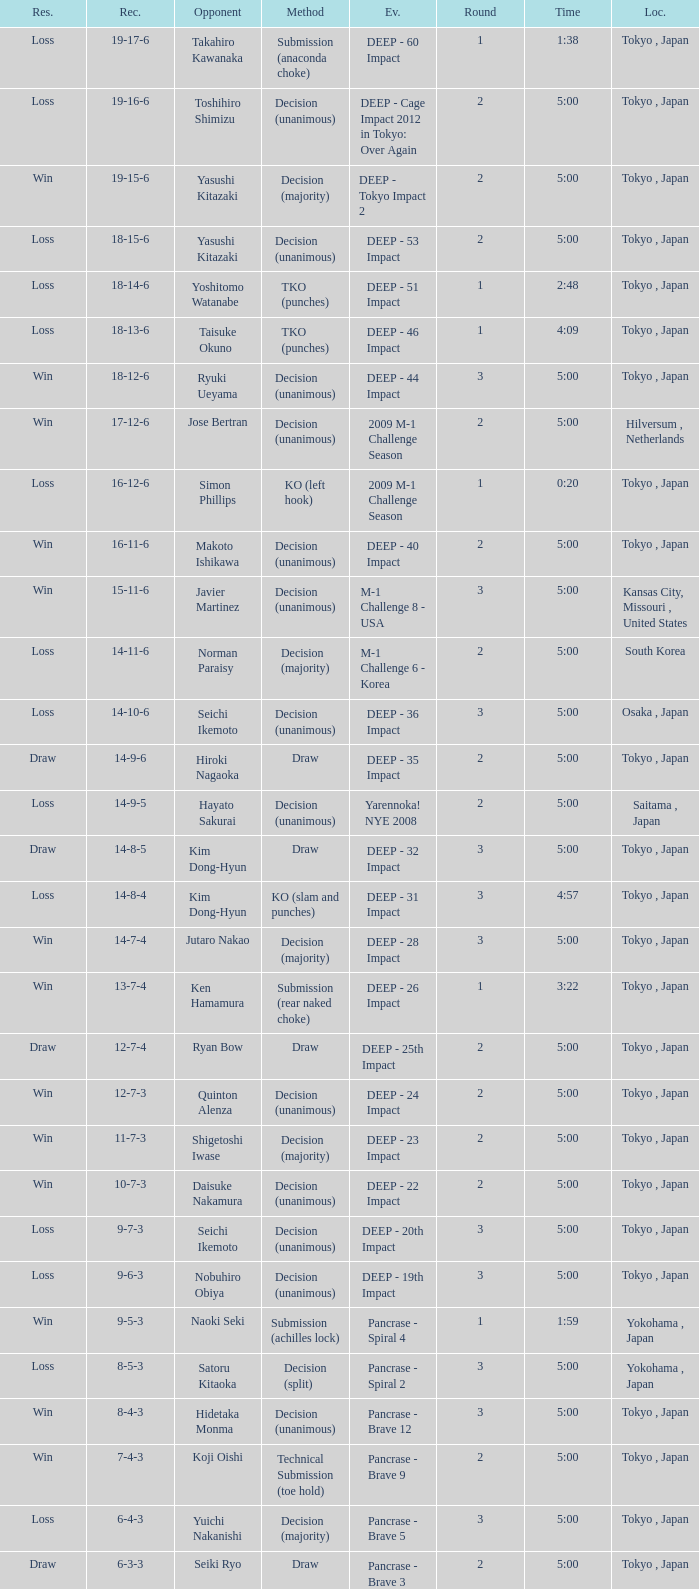What is the location when the record is 5-1-1? Osaka , Japan. 